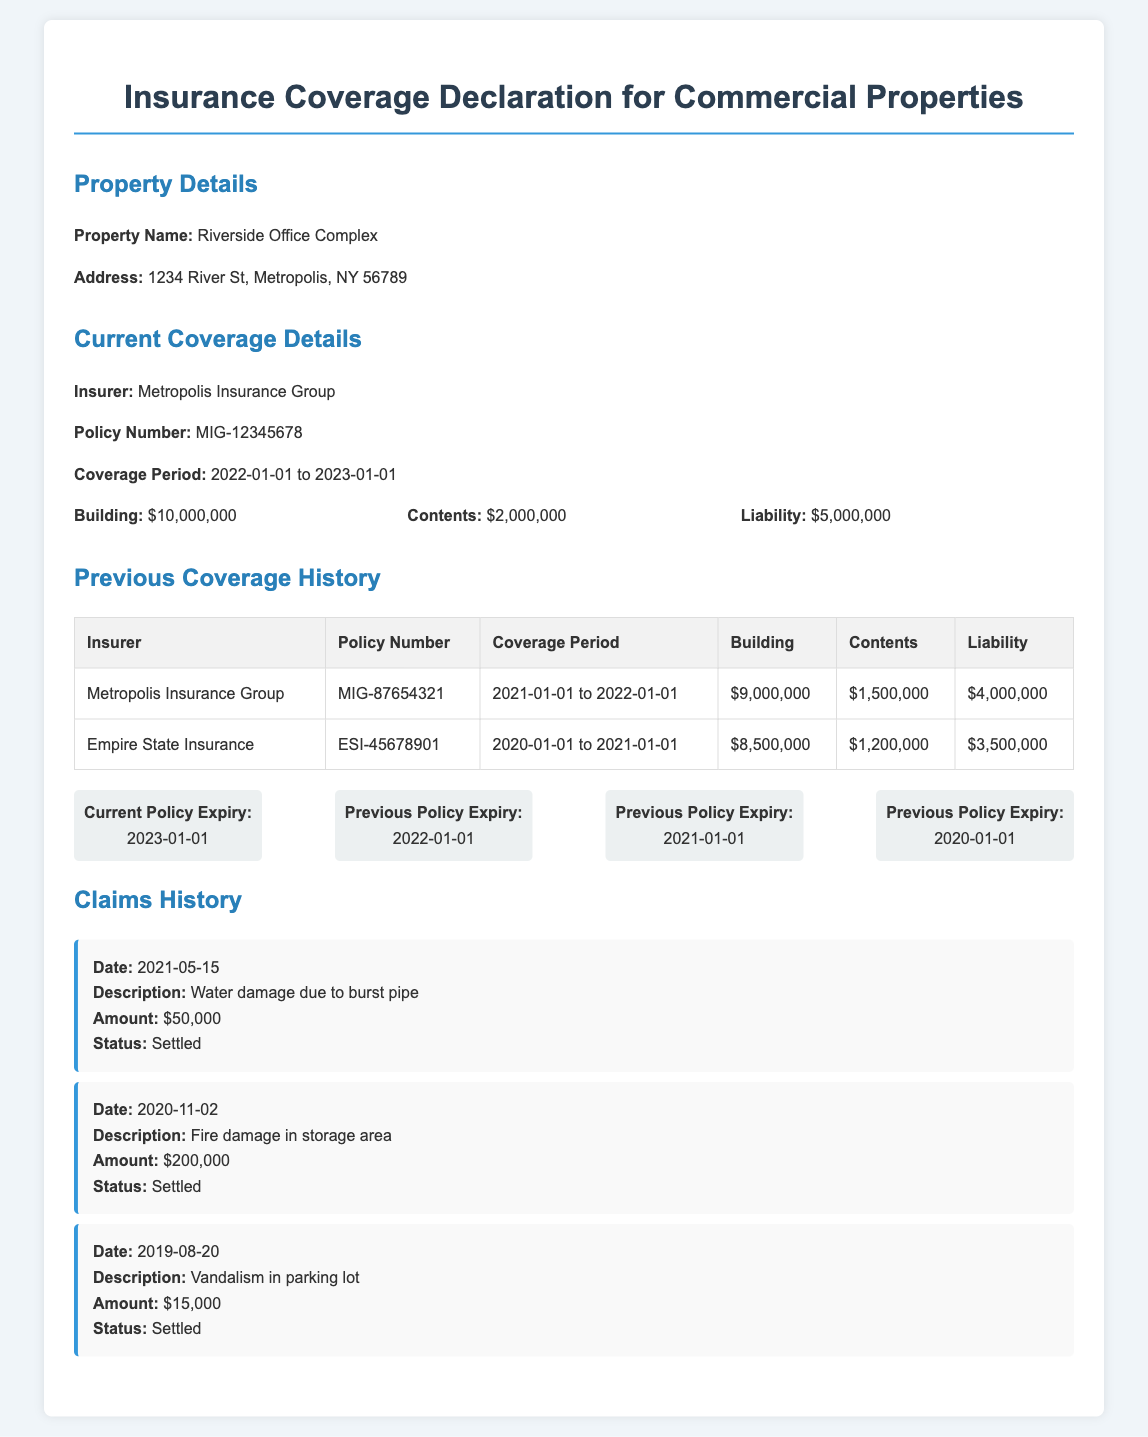What is the property name? The property name is stated in the document under the property details section.
Answer: Riverside Office Complex Who is the insurer? The insurer is mentioned in the current coverage details section.
Answer: Metropolis Insurance Group What is the coverage amount for liabilities? The liability coverage amount is specified in the coverage details.
Answer: $5,000,000 What is the current policy expiry date? The current policy expiry is presented in the expiry dates section.
Answer: 2023-01-01 How much was claimed for fire damage in storage area? The claims history provides a specific claim amount for that incident.
Answer: $200,000 Which insurer provided coverage in 2020? The previous coverage history section lists the insurers for each year.
Answer: Empire State Insurance What is the total coverage for building in the latest policy? The latest building coverage amount is specified in the current coverage details.
Answer: $10,000,000 How many claims were settled in the past five years? The claims history section lists the individual claims that were settled.
Answer: 3 What was the coverage period for the previous policy? The coverage period for the previous policy is explained in the previous coverage history section.
Answer: 2021-01-01 to 2022-01-01 